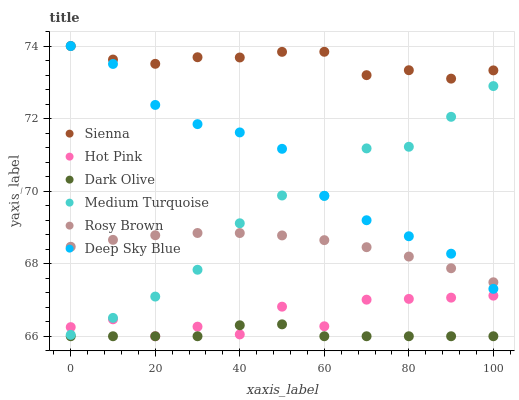Does Dark Olive have the minimum area under the curve?
Answer yes or no. Yes. Does Sienna have the maximum area under the curve?
Answer yes or no. Yes. Does Medium Turquoise have the minimum area under the curve?
Answer yes or no. No. Does Medium Turquoise have the maximum area under the curve?
Answer yes or no. No. Is Rosy Brown the smoothest?
Answer yes or no. Yes. Is Hot Pink the roughest?
Answer yes or no. Yes. Is Medium Turquoise the smoothest?
Answer yes or no. No. Is Medium Turquoise the roughest?
Answer yes or no. No. Does Hot Pink have the lowest value?
Answer yes or no. Yes. Does Medium Turquoise have the lowest value?
Answer yes or no. No. Does Deep Sky Blue have the highest value?
Answer yes or no. Yes. Does Medium Turquoise have the highest value?
Answer yes or no. No. Is Hot Pink less than Rosy Brown?
Answer yes or no. Yes. Is Sienna greater than Hot Pink?
Answer yes or no. Yes. Does Deep Sky Blue intersect Medium Turquoise?
Answer yes or no. Yes. Is Deep Sky Blue less than Medium Turquoise?
Answer yes or no. No. Is Deep Sky Blue greater than Medium Turquoise?
Answer yes or no. No. Does Hot Pink intersect Rosy Brown?
Answer yes or no. No. 